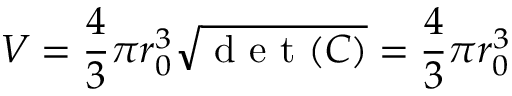Convert formula to latex. <formula><loc_0><loc_0><loc_500><loc_500>V = \frac { 4 } { 3 } \pi r _ { 0 } ^ { 3 } \sqrt { d e t ( C ) } = \frac { 4 } { 3 } \pi r _ { 0 } ^ { 3 }</formula> 